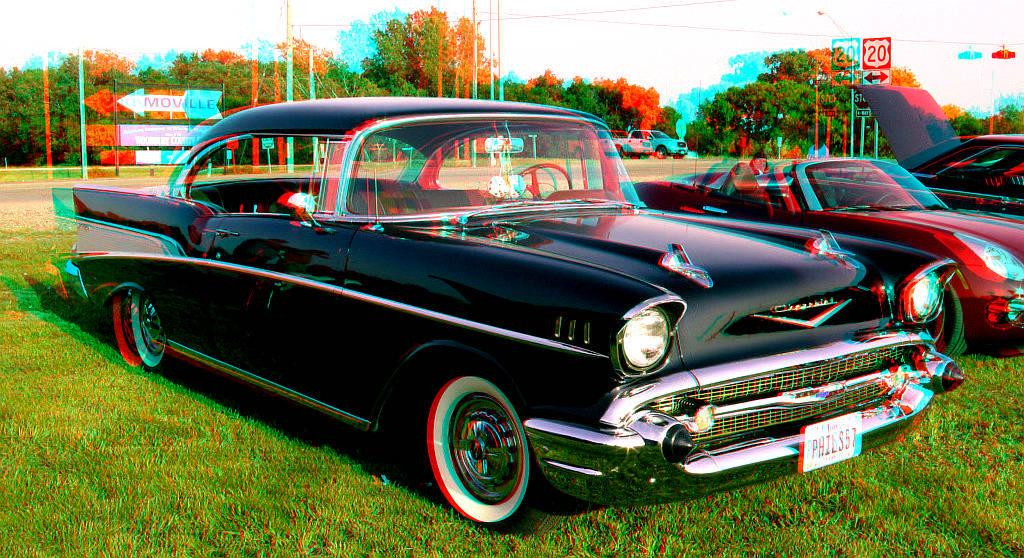What is located in the foreground of the image? There are cars and grass in the foreground of the image. What can be seen in the background of the image? There are trees, at least one car, current poles, cables, sign boards, and grass in the background of the image. How many cars are visible in the image? There are cars in both the foreground and background of the image, so there are at least two cars visible. What type of infrastructure is present in the background of the image? Current poles and cables are present in the background of the image, suggesting some form of electrical infrastructure. What type of truck can be seen in the image? There is no truck present in the image; only cars are mentioned. What type of station is visible in the background of the image? There is no station present in the image; the background features trees, cars, current poles, cables, sign boards, and grass. 